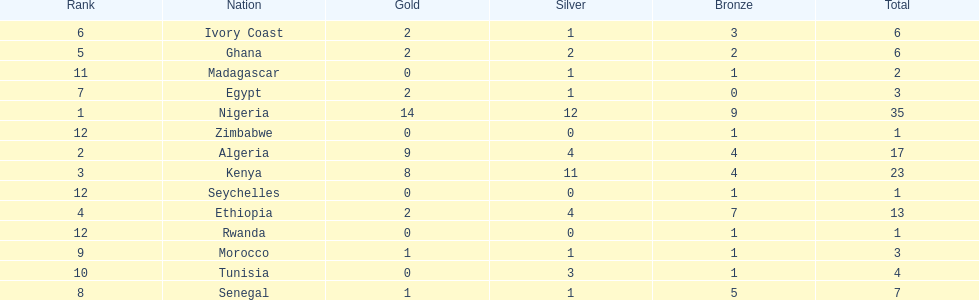Help me parse the entirety of this table. {'header': ['Rank', 'Nation', 'Gold', 'Silver', 'Bronze', 'Total'], 'rows': [['6', 'Ivory Coast', '2', '1', '3', '6'], ['5', 'Ghana', '2', '2', '2', '6'], ['11', 'Madagascar', '0', '1', '1', '2'], ['7', 'Egypt', '2', '1', '0', '3'], ['1', 'Nigeria', '14', '12', '9', '35'], ['12', 'Zimbabwe', '0', '0', '1', '1'], ['2', 'Algeria', '9', '4', '4', '17'], ['3', 'Kenya', '8', '11', '4', '23'], ['12', 'Seychelles', '0', '0', '1', '1'], ['4', 'Ethiopia', '2', '4', '7', '13'], ['12', 'Rwanda', '0', '0', '1', '1'], ['9', 'Morocco', '1', '1', '1', '3'], ['10', 'Tunisia', '0', '3', '1', '4'], ['8', 'Senegal', '1', '1', '5', '7']]} How many silver medals did kenya earn? 11. 